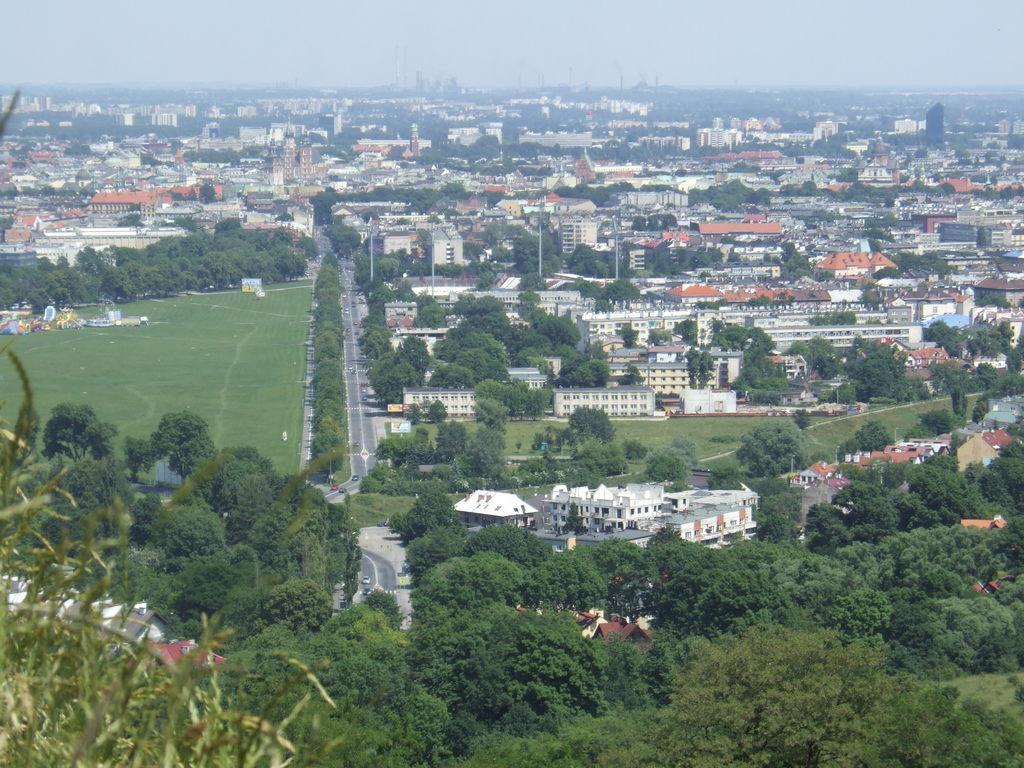How would you summarize this image in a sentence or two? This is an outside view. In this image, I can see many buildings and trees. On the left side, I can see the grass on the ground and there are few vehicles on the roads. At the top of the image I can see the sky. 